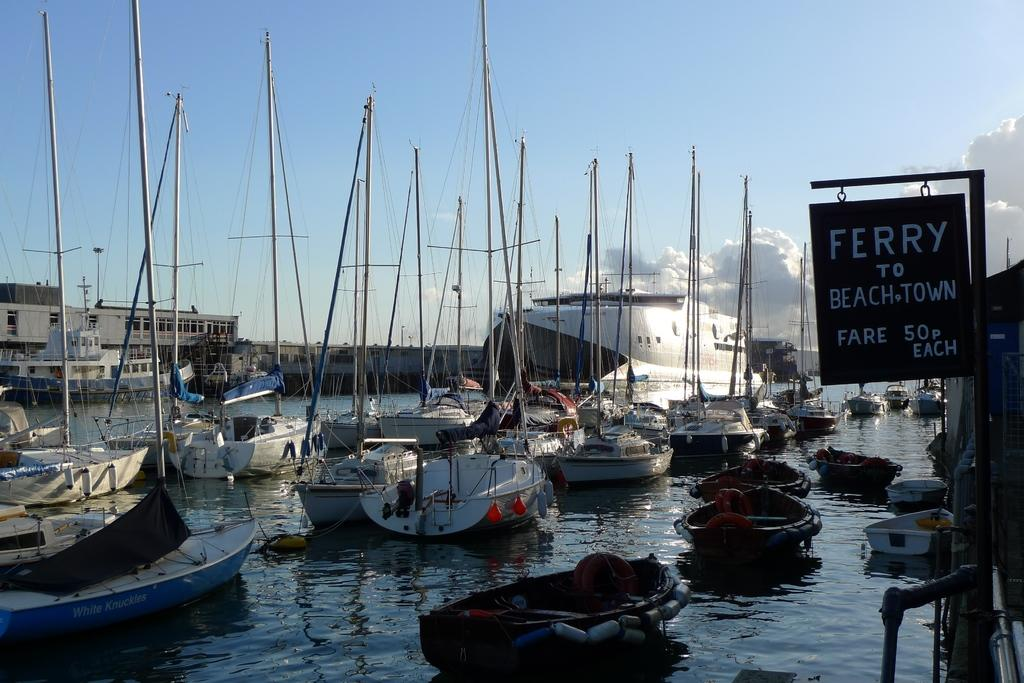<image>
Describe the image concisely. Boats sit in the water near a sign that says Ferry to BeachTown 